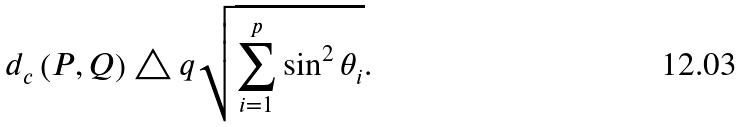<formula> <loc_0><loc_0><loc_500><loc_500>d _ { c } \left ( P , Q \right ) \triangle q \sqrt { \sum _ { i = 1 } ^ { p } \sin ^ { 2 } \theta _ { i } } .</formula> 